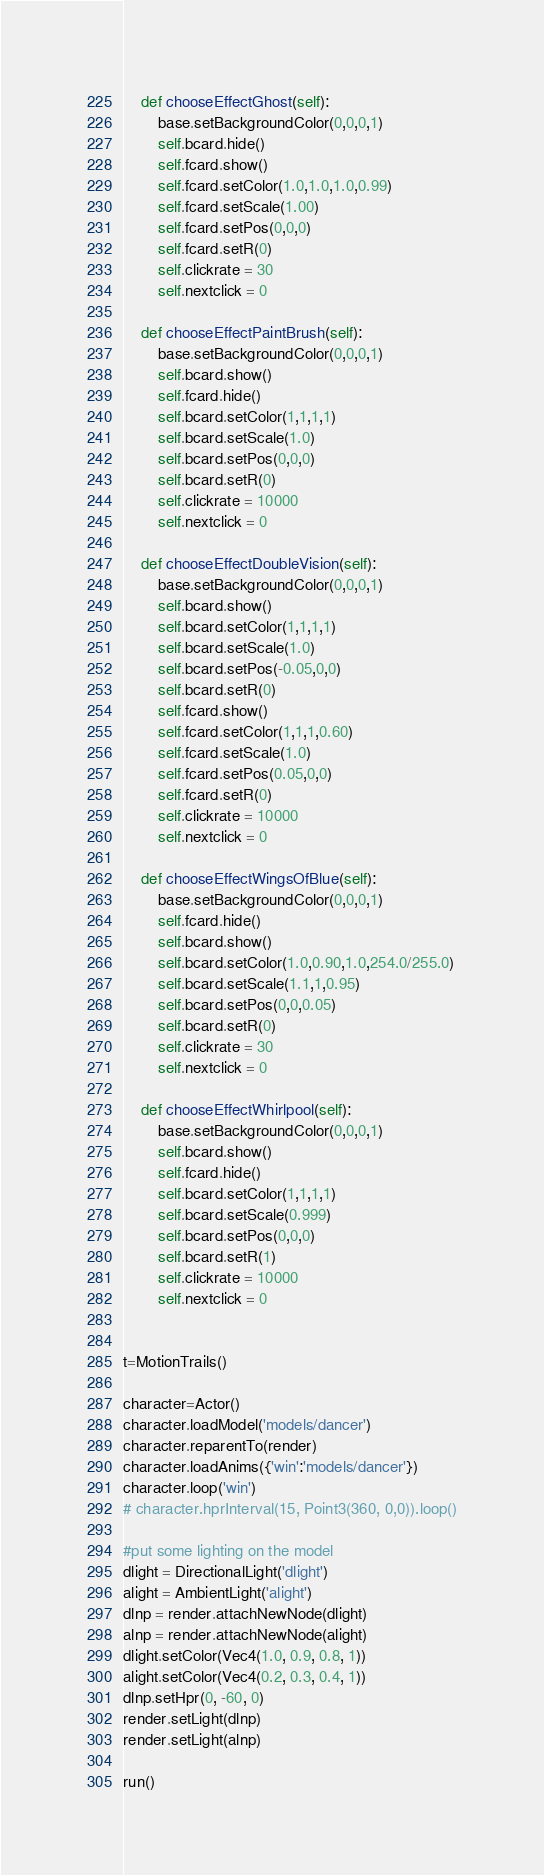<code> <loc_0><loc_0><loc_500><loc_500><_Python_>    def chooseEffectGhost(self):
        base.setBackgroundColor(0,0,0,1)
        self.bcard.hide()
        self.fcard.show()
        self.fcard.setColor(1.0,1.0,1.0,0.99)
        self.fcard.setScale(1.00)
        self.fcard.setPos(0,0,0)
        self.fcard.setR(0)
        self.clickrate = 30
        self.nextclick = 0
        
    def chooseEffectPaintBrush(self):
        base.setBackgroundColor(0,0,0,1)
        self.bcard.show()
        self.fcard.hide()
        self.bcard.setColor(1,1,1,1)
        self.bcard.setScale(1.0)
        self.bcard.setPos(0,0,0)
        self.bcard.setR(0)
        self.clickrate = 10000
        self.nextclick = 0

    def chooseEffectDoubleVision(self):
        base.setBackgroundColor(0,0,0,1)
        self.bcard.show()
        self.bcard.setColor(1,1,1,1)
        self.bcard.setScale(1.0)
        self.bcard.setPos(-0.05,0,0)
        self.bcard.setR(0)
        self.fcard.show()
        self.fcard.setColor(1,1,1,0.60)
        self.fcard.setScale(1.0)
        self.fcard.setPos(0.05,0,0)
        self.fcard.setR(0)
        self.clickrate = 10000
        self.nextclick = 0

    def chooseEffectWingsOfBlue(self):
        base.setBackgroundColor(0,0,0,1)
        self.fcard.hide()
        self.bcard.show()
        self.bcard.setColor(1.0,0.90,1.0,254.0/255.0)
        self.bcard.setScale(1.1,1,0.95)
        self.bcard.setPos(0,0,0.05)
        self.bcard.setR(0)
        self.clickrate = 30
        self.nextclick = 0

    def chooseEffectWhirlpool(self):
        base.setBackgroundColor(0,0,0,1)
        self.bcard.show()
        self.fcard.hide()
        self.bcard.setColor(1,1,1,1)
        self.bcard.setScale(0.999)
        self.bcard.setPos(0,0,0)
        self.bcard.setR(1)
        self.clickrate = 10000
        self.nextclick = 0

        
t=MotionTrails()

character=Actor()
character.loadModel('models/dancer')
character.reparentTo(render)
character.loadAnims({'win':'models/dancer'})
character.loop('win')
# character.hprInterval(15, Point3(360, 0,0)).loop()

#put some lighting on the model
dlight = DirectionalLight('dlight')
alight = AmbientLight('alight')
dlnp = render.attachNewNode(dlight) 
alnp = render.attachNewNode(alight)
dlight.setColor(Vec4(1.0, 0.9, 0.8, 1))
alight.setColor(Vec4(0.2, 0.3, 0.4, 1))
dlnp.setHpr(0, -60, 0) 
render.setLight(dlnp)
render.setLight(alnp)

run()


</code> 